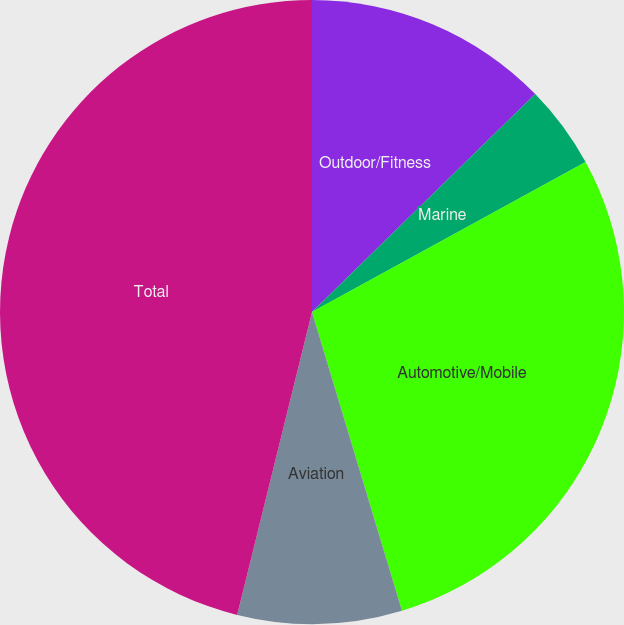Convert chart. <chart><loc_0><loc_0><loc_500><loc_500><pie_chart><fcel>Outdoor/Fitness<fcel>Marine<fcel>Automotive/Mobile<fcel>Aviation<fcel>Total<nl><fcel>12.69%<fcel>4.33%<fcel>28.32%<fcel>8.51%<fcel>46.14%<nl></chart> 